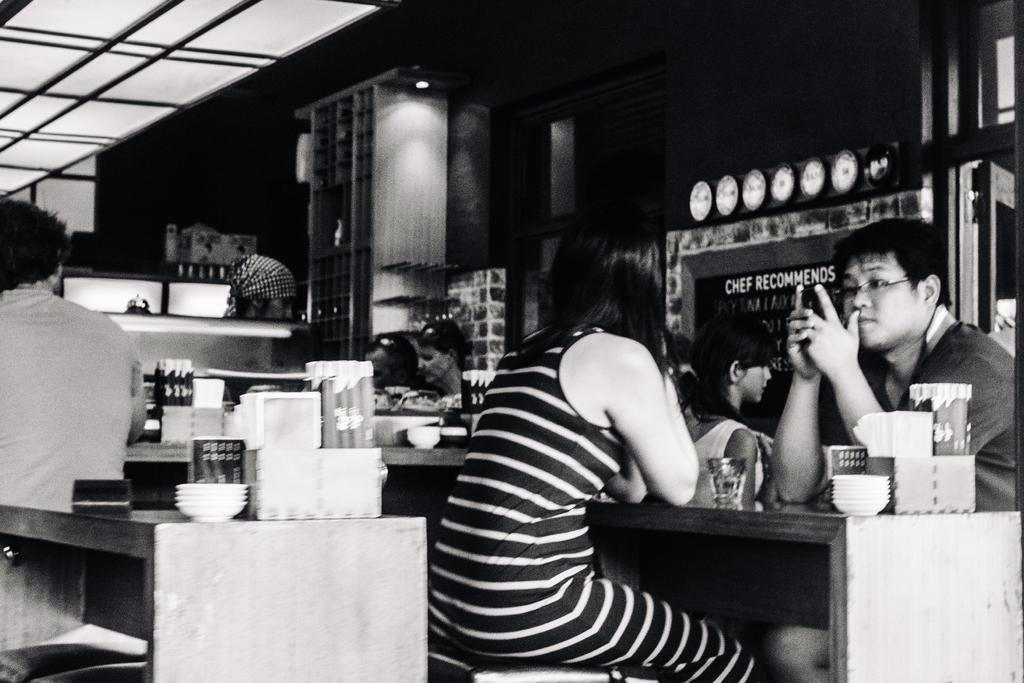What are the people in the image doing? The people in the image are sitting near the tables. What objects can be seen on the tables? There are glasses, bowls, and tissues on the tables. Can you tell me how many basketballs are on the tables in the image? There are no basketballs present on the tables in the image. Is there a cow sitting with the people at the tables in the image? There is no cow present in the image; it only features people sitting near the tables. 